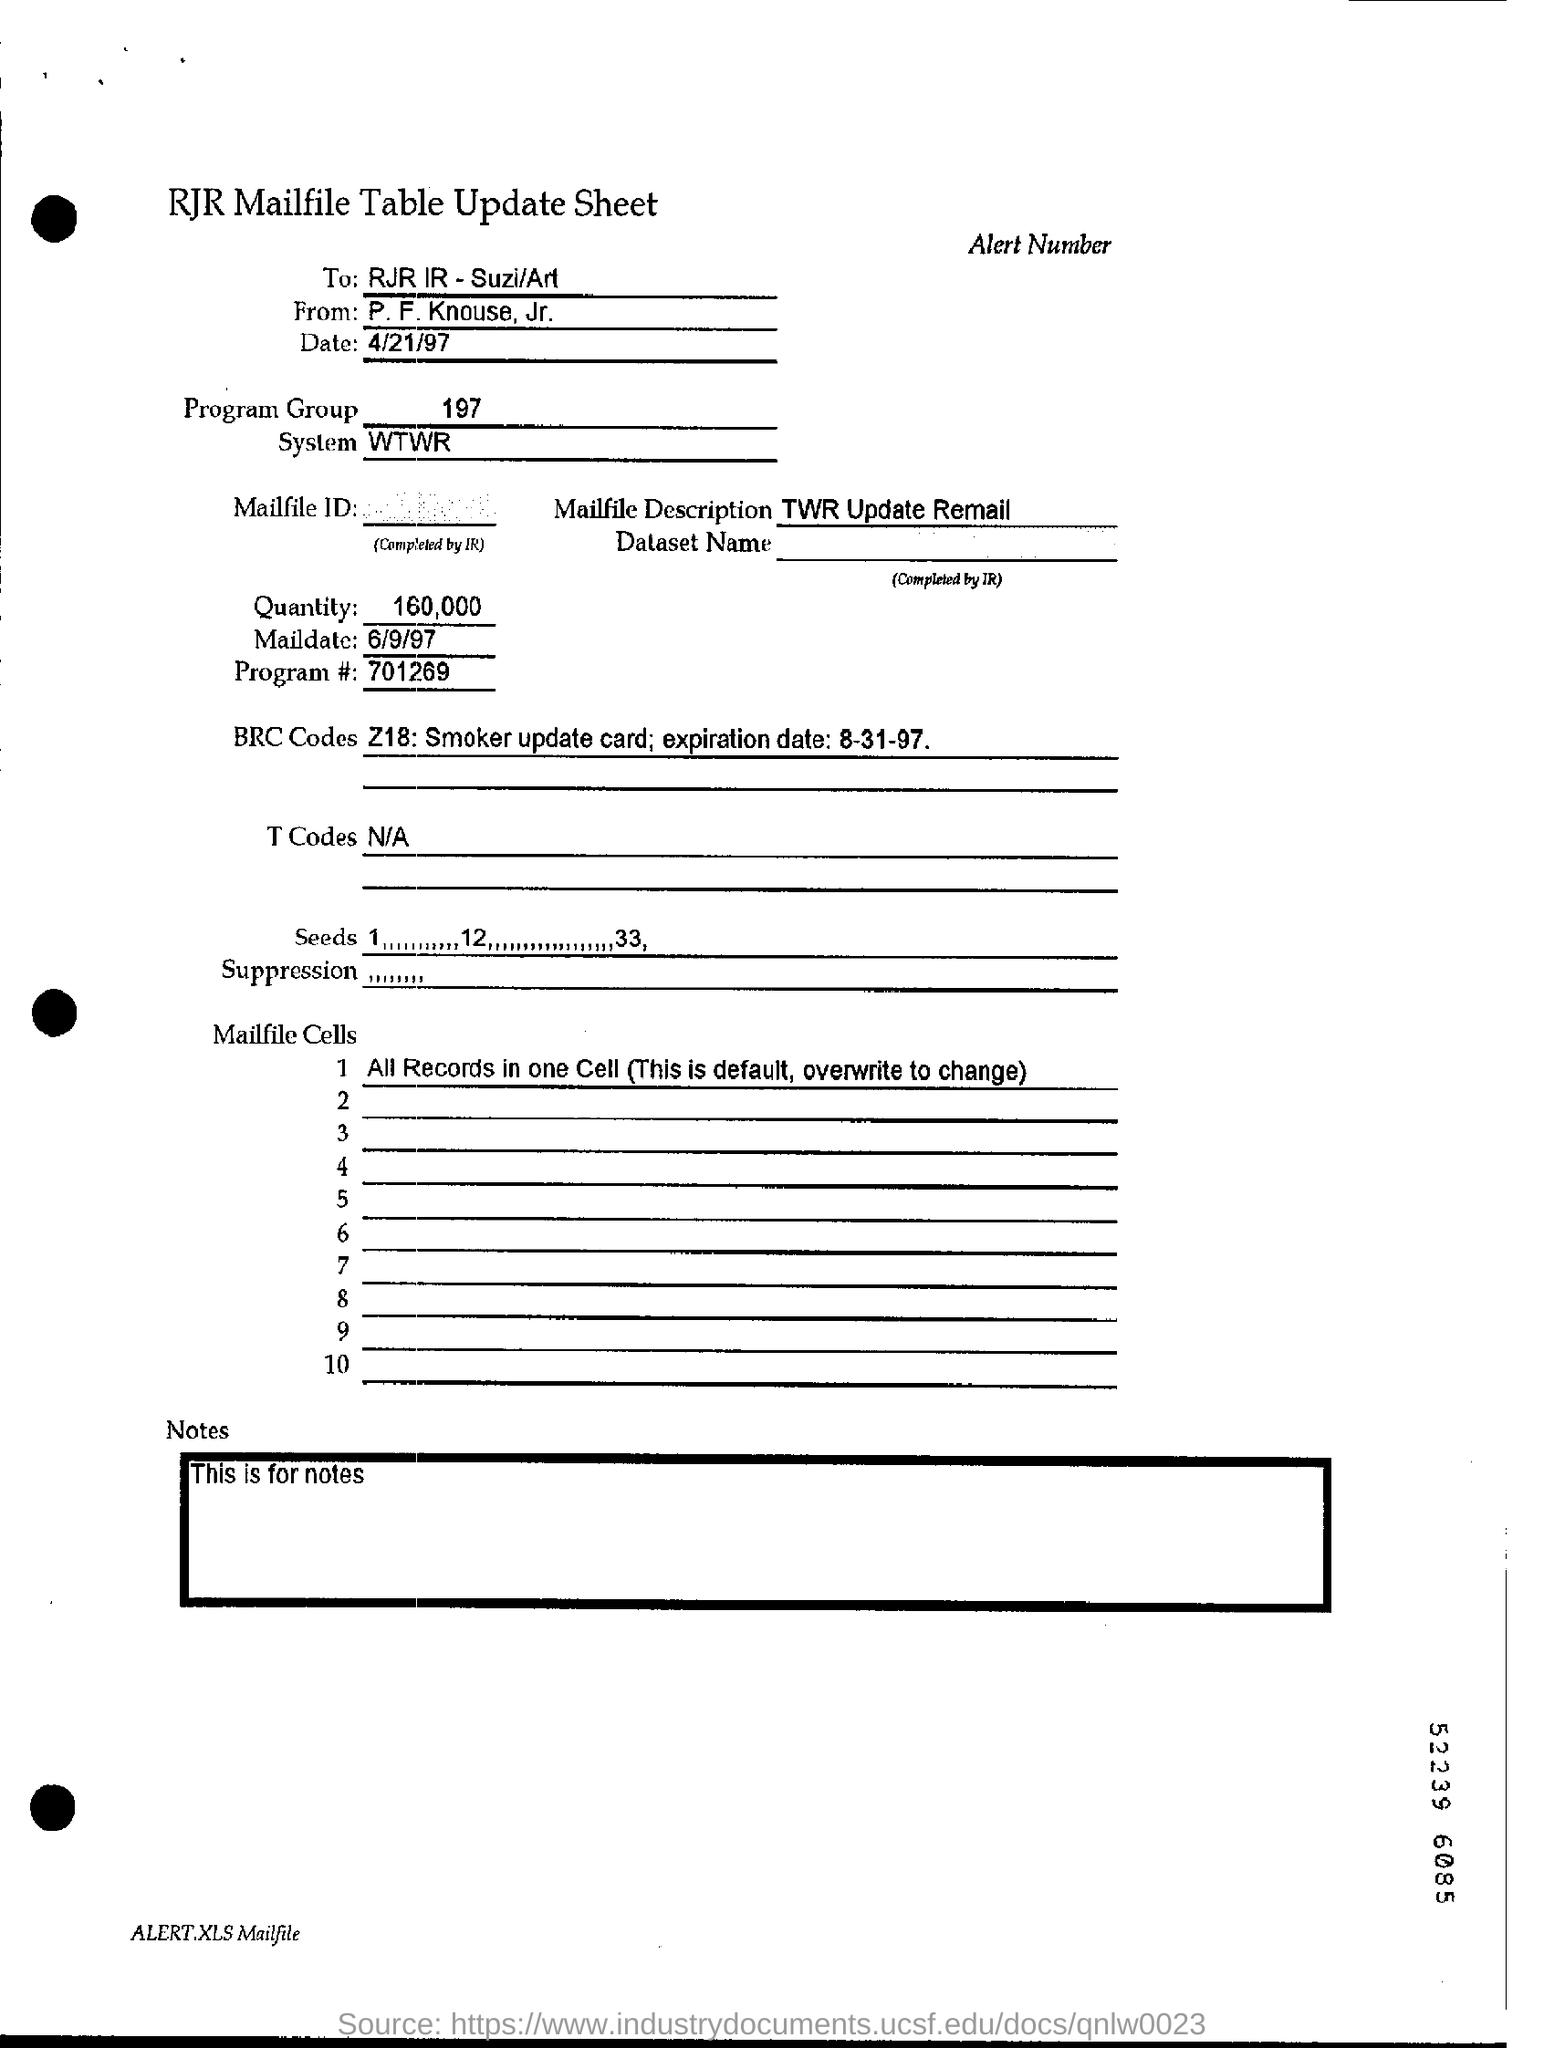List a handful of essential elements in this visual. The question asks for a descriptive sentence that includes the phrase "What is the mailfile description?" and the text "TWR Update Remail.." as provided in the original text. The revised sentence would read: "The mailfile description for TWR Update Remail is...". The quantity mentioned is 160,000. On what date was the mail sent? The program number is 701269... What is the program group specified?" is a question asking for information about a particular program group. The number "197" is likely a reference to the program group in question. 